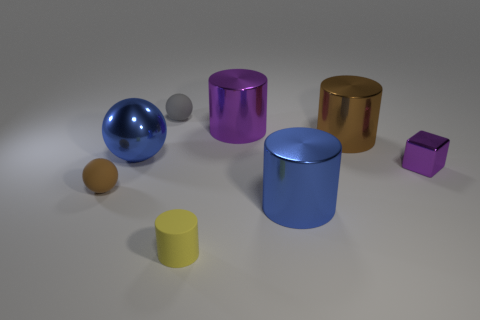There is a tiny thing that is right of the purple metallic object behind the large blue thing that is to the left of the blue cylinder; what is its material?
Keep it short and to the point. Metal. There is a blue thing on the right side of the tiny gray matte sphere; how many small gray things are left of it?
Give a very brief answer. 1. Do the purple object that is on the left side of the brown cylinder and the tiny yellow cylinder have the same size?
Your answer should be very brief. No. How many big blue shiny things are the same shape as the big brown metal object?
Give a very brief answer. 1. The gray object is what shape?
Your answer should be compact. Sphere. Are there an equal number of gray rubber spheres on the right side of the big brown thing and brown matte blocks?
Provide a succinct answer. Yes. Is the material of the small object on the left side of the gray ball the same as the tiny purple object?
Ensure brevity in your answer.  No. Are there fewer gray things that are on the right side of the metal cube than purple spheres?
Keep it short and to the point. No. How many matte objects are large spheres or tiny red cylinders?
Provide a succinct answer. 0. Is there anything else of the same color as the metal sphere?
Provide a succinct answer. Yes. 